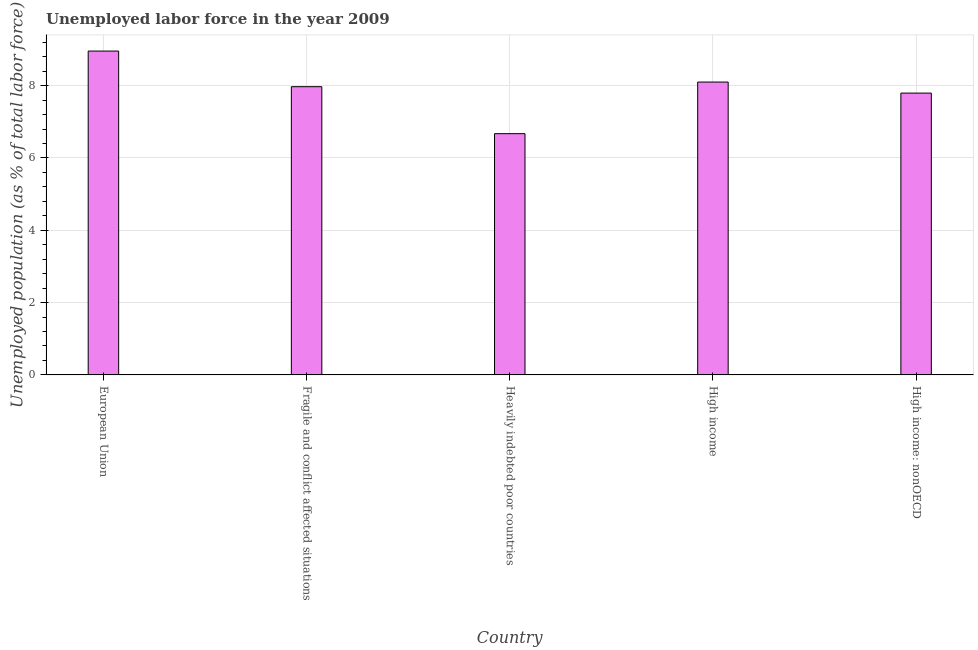Does the graph contain grids?
Your response must be concise. Yes. What is the title of the graph?
Your response must be concise. Unemployed labor force in the year 2009. What is the label or title of the X-axis?
Offer a very short reply. Country. What is the label or title of the Y-axis?
Offer a very short reply. Unemployed population (as % of total labor force). What is the total unemployed population in High income: nonOECD?
Your answer should be compact. 7.79. Across all countries, what is the maximum total unemployed population?
Make the answer very short. 8.96. Across all countries, what is the minimum total unemployed population?
Make the answer very short. 6.67. In which country was the total unemployed population minimum?
Provide a succinct answer. Heavily indebted poor countries. What is the sum of the total unemployed population?
Ensure brevity in your answer.  39.49. What is the difference between the total unemployed population in Fragile and conflict affected situations and High income: nonOECD?
Your response must be concise. 0.18. What is the average total unemployed population per country?
Your answer should be very brief. 7.9. What is the median total unemployed population?
Your response must be concise. 7.97. What is the ratio of the total unemployed population in European Union to that in Fragile and conflict affected situations?
Provide a succinct answer. 1.12. Is the total unemployed population in European Union less than that in High income?
Keep it short and to the point. No. Is the difference between the total unemployed population in European Union and High income: nonOECD greater than the difference between any two countries?
Offer a very short reply. No. What is the difference between the highest and the second highest total unemployed population?
Provide a succinct answer. 0.86. What is the difference between the highest and the lowest total unemployed population?
Provide a succinct answer. 2.28. How many bars are there?
Provide a short and direct response. 5. What is the difference between two consecutive major ticks on the Y-axis?
Ensure brevity in your answer.  2. What is the Unemployed population (as % of total labor force) in European Union?
Your response must be concise. 8.96. What is the Unemployed population (as % of total labor force) of Fragile and conflict affected situations?
Offer a terse response. 7.97. What is the Unemployed population (as % of total labor force) of Heavily indebted poor countries?
Offer a terse response. 6.67. What is the Unemployed population (as % of total labor force) in High income?
Offer a terse response. 8.1. What is the Unemployed population (as % of total labor force) of High income: nonOECD?
Make the answer very short. 7.79. What is the difference between the Unemployed population (as % of total labor force) in European Union and Fragile and conflict affected situations?
Make the answer very short. 0.99. What is the difference between the Unemployed population (as % of total labor force) in European Union and Heavily indebted poor countries?
Your answer should be compact. 2.28. What is the difference between the Unemployed population (as % of total labor force) in European Union and High income?
Give a very brief answer. 0.86. What is the difference between the Unemployed population (as % of total labor force) in European Union and High income: nonOECD?
Provide a short and direct response. 1.16. What is the difference between the Unemployed population (as % of total labor force) in Fragile and conflict affected situations and Heavily indebted poor countries?
Ensure brevity in your answer.  1.3. What is the difference between the Unemployed population (as % of total labor force) in Fragile and conflict affected situations and High income?
Make the answer very short. -0.13. What is the difference between the Unemployed population (as % of total labor force) in Fragile and conflict affected situations and High income: nonOECD?
Provide a short and direct response. 0.18. What is the difference between the Unemployed population (as % of total labor force) in Heavily indebted poor countries and High income?
Keep it short and to the point. -1.43. What is the difference between the Unemployed population (as % of total labor force) in Heavily indebted poor countries and High income: nonOECD?
Offer a terse response. -1.12. What is the difference between the Unemployed population (as % of total labor force) in High income and High income: nonOECD?
Make the answer very short. 0.31. What is the ratio of the Unemployed population (as % of total labor force) in European Union to that in Fragile and conflict affected situations?
Provide a succinct answer. 1.12. What is the ratio of the Unemployed population (as % of total labor force) in European Union to that in Heavily indebted poor countries?
Offer a very short reply. 1.34. What is the ratio of the Unemployed population (as % of total labor force) in European Union to that in High income?
Offer a terse response. 1.11. What is the ratio of the Unemployed population (as % of total labor force) in European Union to that in High income: nonOECD?
Your answer should be compact. 1.15. What is the ratio of the Unemployed population (as % of total labor force) in Fragile and conflict affected situations to that in Heavily indebted poor countries?
Provide a short and direct response. 1.2. What is the ratio of the Unemployed population (as % of total labor force) in Fragile and conflict affected situations to that in High income?
Provide a short and direct response. 0.98. What is the ratio of the Unemployed population (as % of total labor force) in Fragile and conflict affected situations to that in High income: nonOECD?
Ensure brevity in your answer.  1.02. What is the ratio of the Unemployed population (as % of total labor force) in Heavily indebted poor countries to that in High income?
Provide a succinct answer. 0.82. What is the ratio of the Unemployed population (as % of total labor force) in Heavily indebted poor countries to that in High income: nonOECD?
Offer a very short reply. 0.86. What is the ratio of the Unemployed population (as % of total labor force) in High income to that in High income: nonOECD?
Your response must be concise. 1.04. 